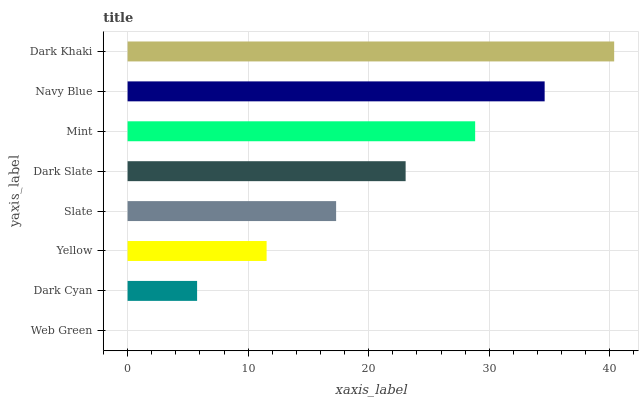Is Web Green the minimum?
Answer yes or no. Yes. Is Dark Khaki the maximum?
Answer yes or no. Yes. Is Dark Cyan the minimum?
Answer yes or no. No. Is Dark Cyan the maximum?
Answer yes or no. No. Is Dark Cyan greater than Web Green?
Answer yes or no. Yes. Is Web Green less than Dark Cyan?
Answer yes or no. Yes. Is Web Green greater than Dark Cyan?
Answer yes or no. No. Is Dark Cyan less than Web Green?
Answer yes or no. No. Is Dark Slate the high median?
Answer yes or no. Yes. Is Slate the low median?
Answer yes or no. Yes. Is Yellow the high median?
Answer yes or no. No. Is Yellow the low median?
Answer yes or no. No. 